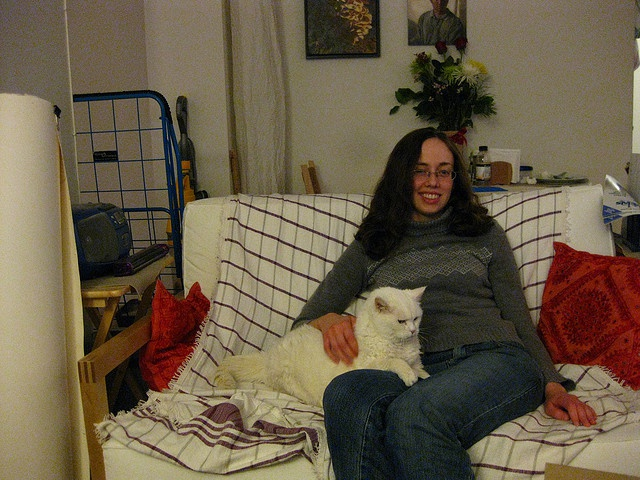Describe the objects in this image and their specific colors. I can see couch in gray, tan, maroon, and black tones, people in gray, black, and maroon tones, cat in gray and tan tones, bottle in gray, black, and olive tones, and chair in gray, olive, black, and maroon tones in this image. 